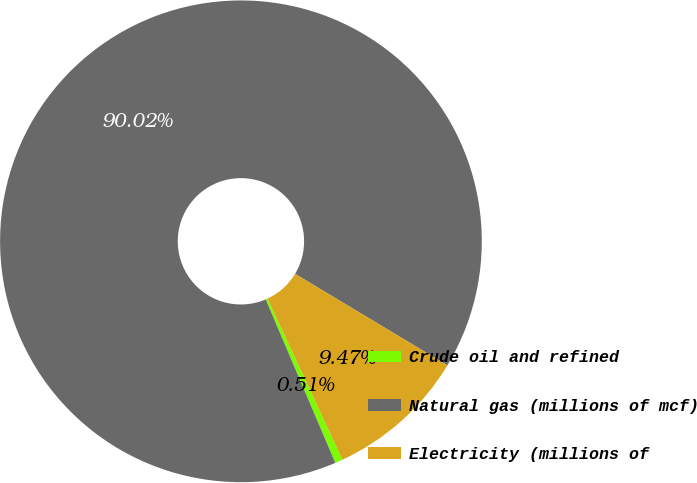Convert chart. <chart><loc_0><loc_0><loc_500><loc_500><pie_chart><fcel>Crude oil and refined<fcel>Natural gas (millions of mcf)<fcel>Electricity (millions of<nl><fcel>0.51%<fcel>90.02%<fcel>9.47%<nl></chart> 